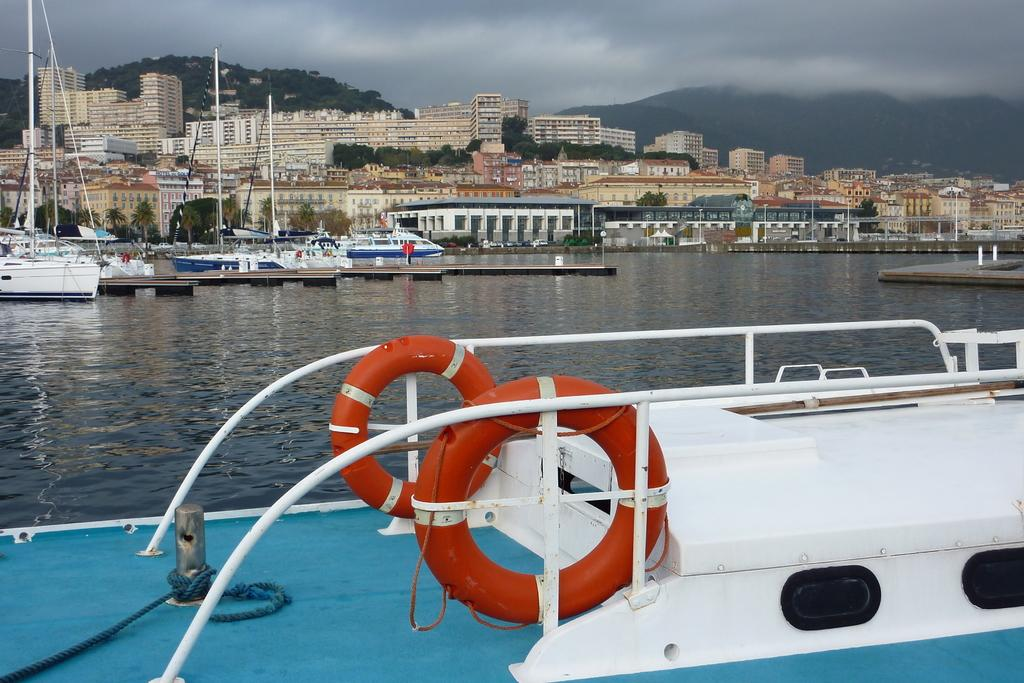What is there are multiple boats in the image, what are they on? The boats are on water. What can be seen in the background of the image? There are buildings and mountains visible in the background of the image. How are the mountains described? The mountains are filled with trees. Can you see a leaf falling from one of the trees on the mountains in the image? There is no leaf falling from a tree in the image; it only shows boats on water and the background elements. 